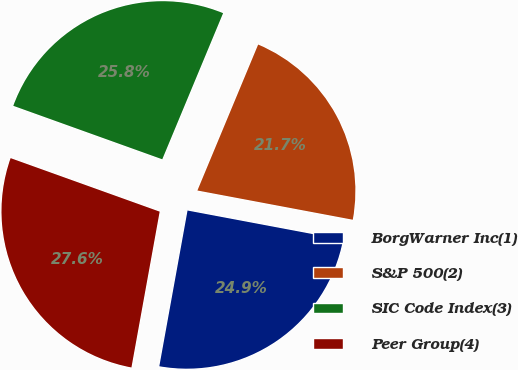Convert chart to OTSL. <chart><loc_0><loc_0><loc_500><loc_500><pie_chart><fcel>BorgWarner Inc(1)<fcel>S&P 500(2)<fcel>SIC Code Index(3)<fcel>Peer Group(4)<nl><fcel>24.89%<fcel>21.68%<fcel>25.79%<fcel>27.63%<nl></chart> 